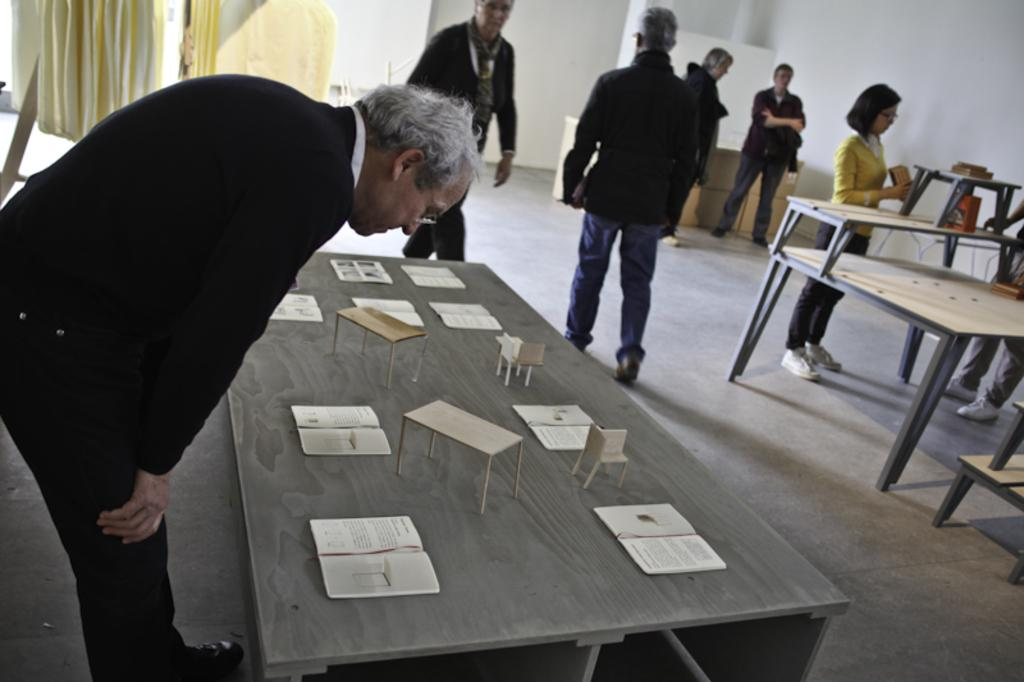How many people are in the image? There is a group of people in the image. What are the people in the image doing? The people are standing. What can be seen on the table in the image? There are objects on a table in the image, including books. What type of window treatment is present in the image? There are curtains in the image. What type of creature can be seen touching the clouds in the image? There are no clouds or creatures present in the image. 